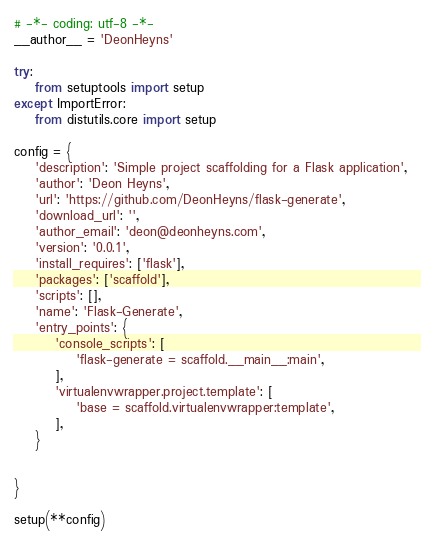Convert code to text. <code><loc_0><loc_0><loc_500><loc_500><_Python_># -*- coding: utf-8 -*-
__author__ = 'DeonHeyns'

try:
    from setuptools import setup
except ImportError:
    from distutils.core import setup

config = {
    'description': 'Simple project scaffolding for a Flask application',
    'author': 'Deon Heyns',
    'url': 'https://github.com/DeonHeyns/flask-generate',
    'download_url': '',
    'author_email': 'deon@deonheyns.com',
    'version': '0.0.1',
    'install_requires': ['flask'],
    'packages': ['scaffold'],
    'scripts': [],
    'name': 'Flask-Generate',
    'entry_points': {
        'console_scripts': [
            'flask-generate = scaffold.__main__:main',
        ],
        'virtualenvwrapper.project.template': [
            'base = scaffold.virtualenvwrapper:template',
        ],
    }


}

setup(**config)</code> 